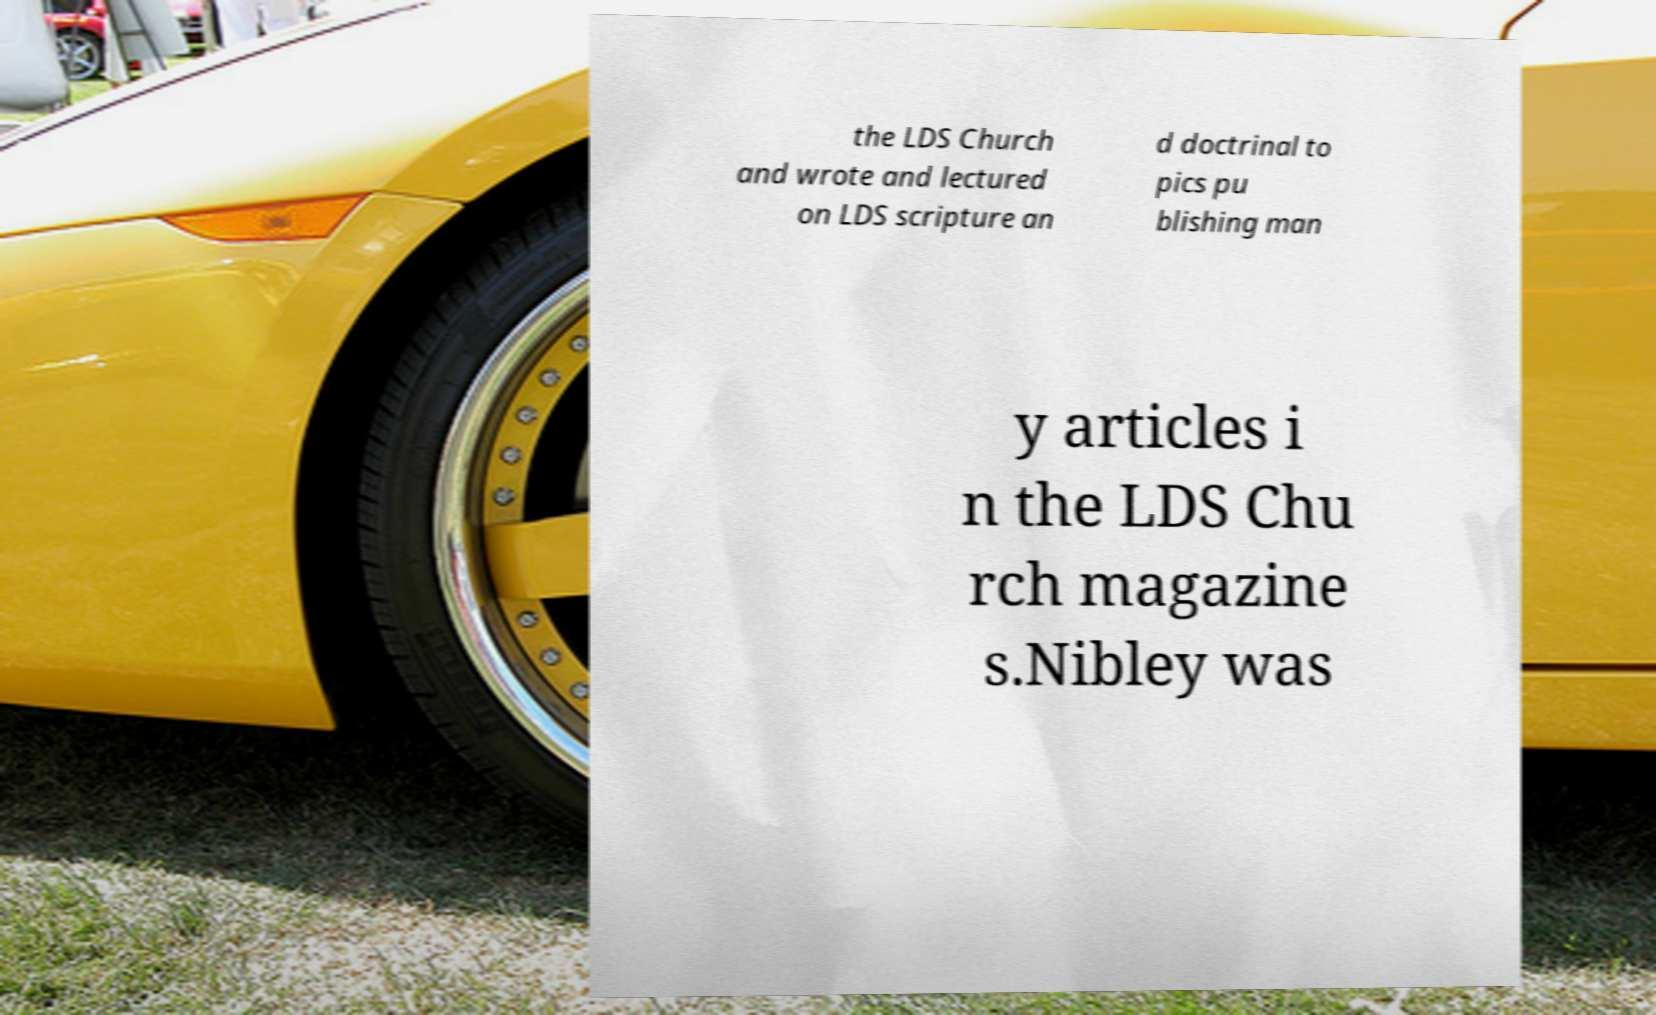Could you assist in decoding the text presented in this image and type it out clearly? the LDS Church and wrote and lectured on LDS scripture an d doctrinal to pics pu blishing man y articles i n the LDS Chu rch magazine s.Nibley was 